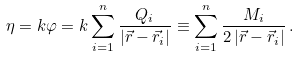Convert formula to latex. <formula><loc_0><loc_0><loc_500><loc_500>\eta = k \varphi = k \sum _ { i = 1 } ^ { n } \frac { Q _ { i } } { | \vec { r } - \vec { r } _ { i } | } \equiv \sum _ { i = 1 } ^ { n } \frac { M _ { i } } { 2 \, | \vec { r } - \vec { r } _ { i } | } \, .</formula> 